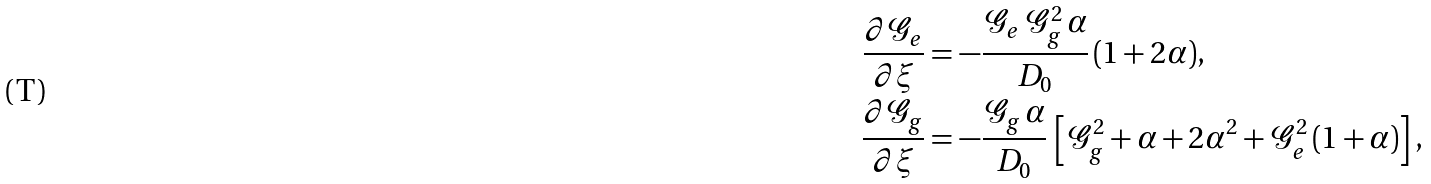<formula> <loc_0><loc_0><loc_500><loc_500>\frac { \partial \mathcal { G } _ { e } } { \partial \xi } & = - \frac { \mathcal { G } _ { e } \, \mathcal { G } _ { g } ^ { 2 } \, \alpha } { D _ { 0 } } \, ( 1 + 2 \alpha ) , \\ \frac { \partial \mathcal { G } _ { g } } { \partial \xi } & = - \frac { \mathcal { G } _ { g } \, \alpha } { D _ { 0 } } \, \left [ \mathcal { G } _ { g } ^ { 2 } + \alpha + 2 \alpha ^ { 2 } + \mathcal { G } _ { e } ^ { 2 } \, ( 1 + \alpha ) \right ] ,</formula> 